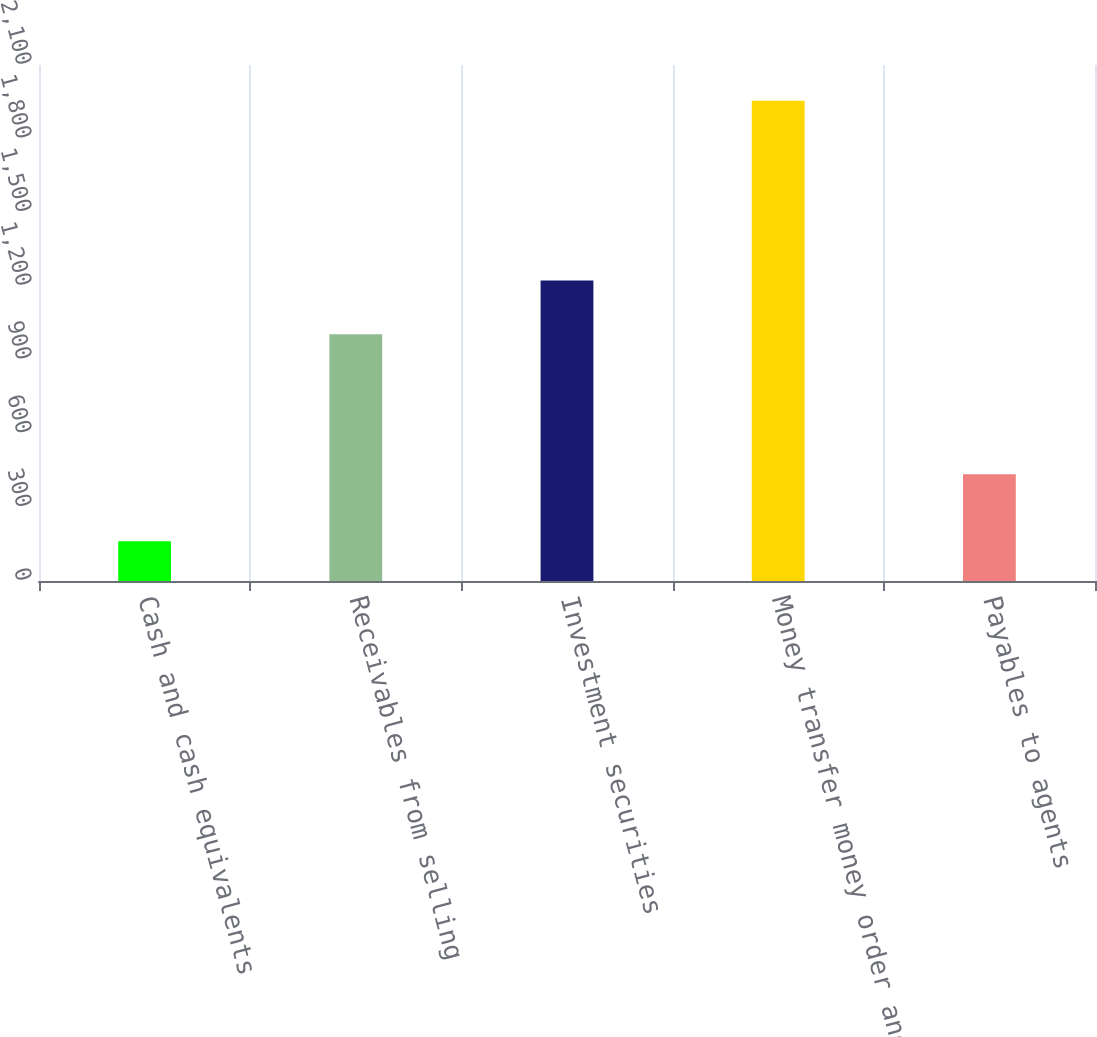<chart> <loc_0><loc_0><loc_500><loc_500><bar_chart><fcel>Cash and cash equivalents<fcel>Receivables from selling<fcel>Investment securities<fcel>Money transfer money order and<fcel>Payables to agents<nl><fcel>161.9<fcel>1004.4<fcel>1222.8<fcel>1954.8<fcel>434.3<nl></chart> 